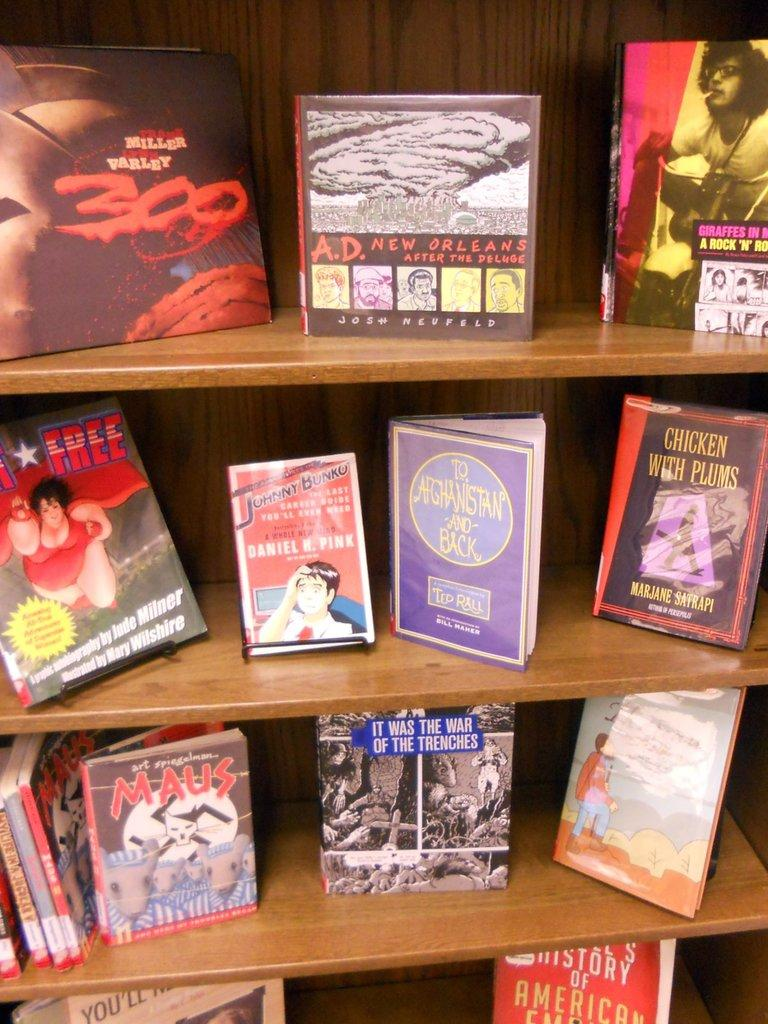<image>
Provide a brief description of the given image. A bookshelf with books including To Afganistan and Back. 